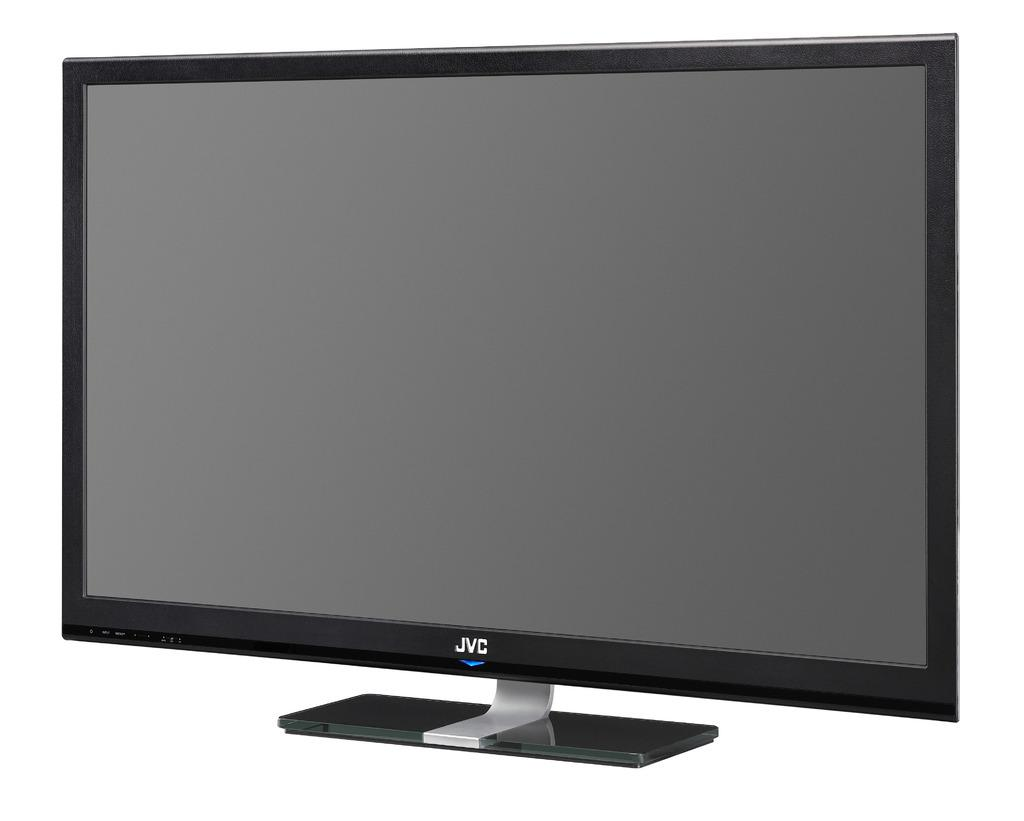<image>
Describe the image concisely. A black TV says JVC and is on a white background. 